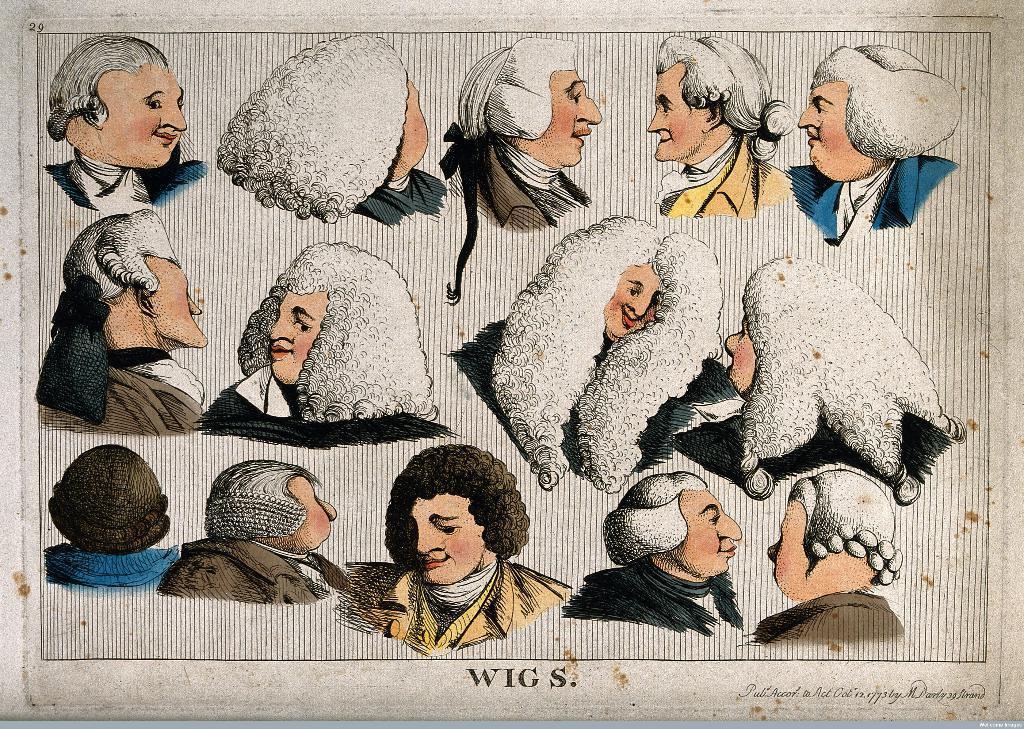Please provide a concise description of this image. In this image, we can see a poster with some images and text. 